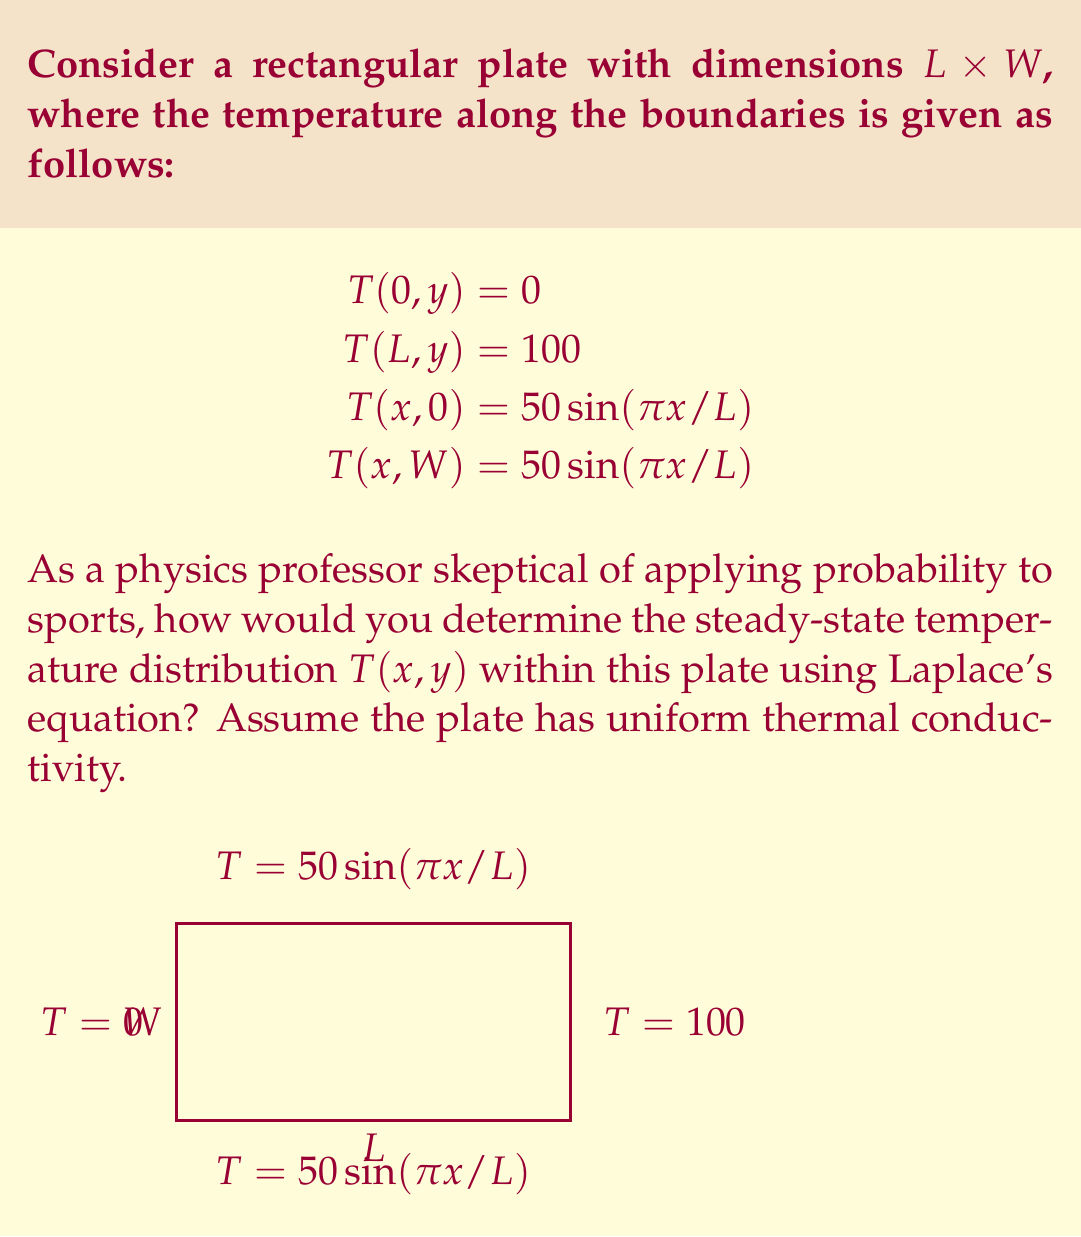Teach me how to tackle this problem. To solve this problem, we follow these steps:

1) The steady-state temperature distribution in a 2D plate with uniform thermal conductivity is governed by Laplace's equation:

   $$\frac{\partial^2 T}{\partial x^2} + \frac{\partial^2 T}{\partial y^2} = 0$$

2) Given the boundary conditions, we can use the method of separation of variables. Assume a solution of the form:

   $$T(x,y) = X(x)Y(y)$$

3) Substituting this into Laplace's equation:

   $$X''(x)Y(y) + X(x)Y''(y) = 0$$
   $$\frac{X''(x)}{X(x)} = -\frac{Y''(y)}{Y(y)} = -\lambda^2$$

4) This gives us two ordinary differential equations:

   $$X''(x) + \lambda^2 X(x) = 0$$
   $$Y''(y) - \lambda^2 Y(y) = 0$$

5) The general solutions are:

   $$X(x) = A\cos(\lambda x) + B\sin(\lambda x)$$
   $$Y(y) = Ce^{\lambda y} + De^{-\lambda y}$$

6) Applying the boundary conditions at $x=0$ and $x=L$:

   $$X(0) = 0 \implies A = 0$$
   $$X(L) = 100 \implies B\sin(\lambda L) = 100$$

7) The boundary conditions at $y=0$ and $y=W$ suggest that $\lambda = \pi/L$. This gives:

   $$X(x) = 100\sin(\pi x/L)$$

8) For $Y(y)$, we need:

   $$Y(0) = Y(W) = \frac{1}{2}$$

   This leads to:

   $$Y(y) = \frac{1}{2}\left(\frac{\sinh(\pi(W-y)/L)}{\sinh(\pi W/L)} + \frac{\sinh(\pi y/L)}{\sinh(\pi W/L)}\right)$$

9) The complete solution is therefore:

   $$T(x,y) = 50\sin(\pi x/L)\left(\frac{\sinh(\pi(W-y)/L)}{\sinh(\pi W/L)} + \frac{\sinh(\pi y/L)}{\sinh(\pi W/L)}\right)$$

This solution satisfies Laplace's equation and all boundary conditions.
Answer: $$T(x,y) = 50\sin(\pi x/L)\left(\frac{\sinh(\pi(W-y)/L)}{\sinh(\pi W/L)} + \frac{\sinh(\pi y/L)}{\sinh(\pi W/L)}\right)$$ 